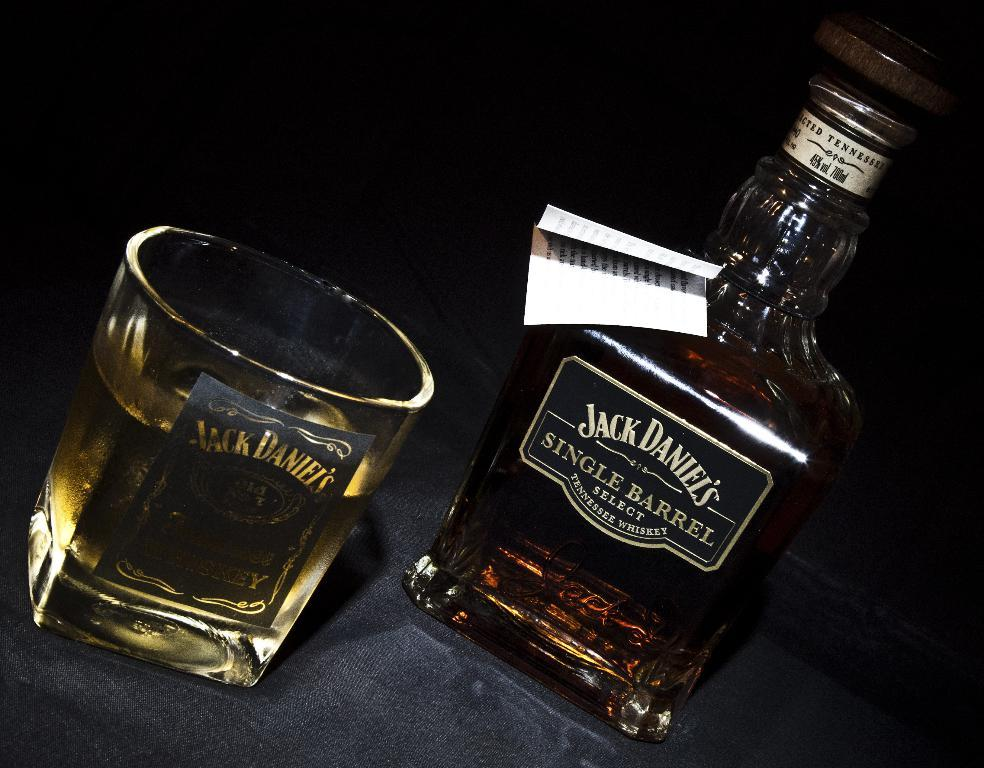<image>
Offer a succinct explanation of the picture presented. A full glass sits next to a bottle of Jack Daniels. 